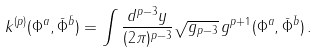Convert formula to latex. <formula><loc_0><loc_0><loc_500><loc_500>k ^ { ( p ) } ( \Phi ^ { a } , \bar { \Phi } ^ { \bar { b } } ) = \int \frac { d ^ { p - 3 } y } { ( 2 \pi ) ^ { p - 3 } } \sqrt { g _ { p - 3 } } \, g ^ { p + 1 } ( \Phi ^ { a } , \bar { \Phi } ^ { \bar { b } } ) \, .</formula> 